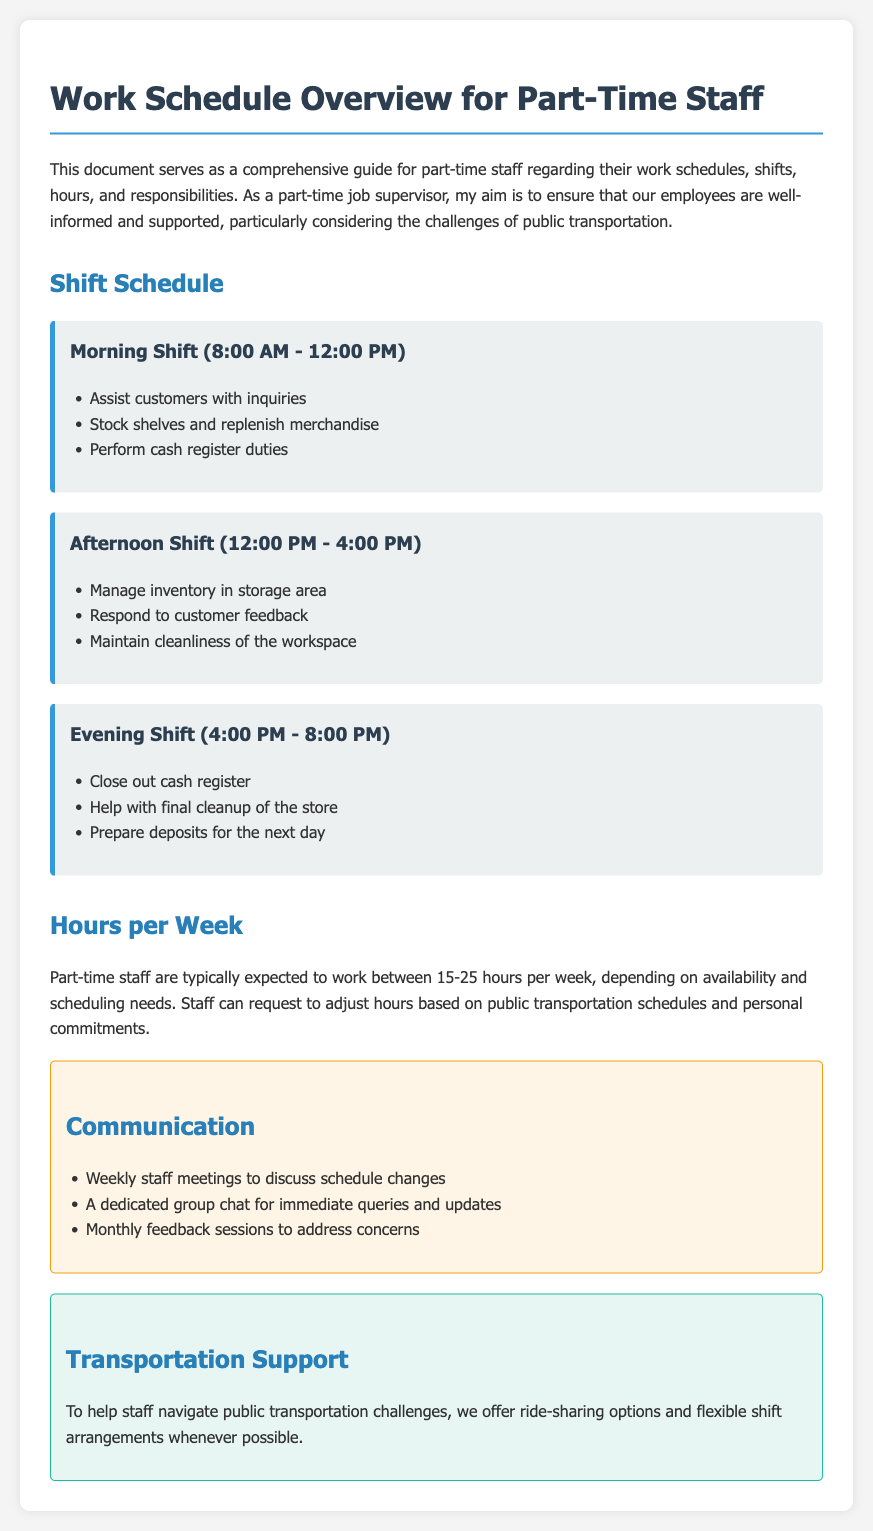What is the morning shift time? The morning shift time is mentioned in the document as starting at 8:00 AM and ending at 12:00 PM.
Answer: 8:00 AM - 12:00 PM How many hours per week are part-time staff typically expected to work? The document states that part-time staff are expected to work between 15-25 hours each week.
Answer: 15-25 hours What is one responsibility during the evening shift? One of the listed responsibilities for the evening shift is to help with the final cleanup of the store.
Answer: Help with final cleanup What type of communication is mentioned for staff meetings? The document mentions that there are weekly staff meetings to discuss schedule changes.
Answer: Weekly staff meetings What support is offered to navigate transportation challenges? The document states that ride-sharing options and flexible shift arrangements are offered to help with transportation issues.
Answer: Ride-sharing options and flexible shift arrangements What is the title of this document? The title of the document is specified at the beginning as "Work Schedule Overview for Part-Time Staff."
Answer: Work Schedule Overview for Part-Time Staff What is the responsibility during the morning shift related to merchandise? One responsibility during the morning shift is to stock shelves and replenish merchandise.
Answer: Stock shelves and replenish merchandise What is the purpose of the document? The purpose is to serve as a comprehensive guide for part-time staff regarding their work schedules and responsibilities.
Answer: Comprehensive guide for part-time staff 